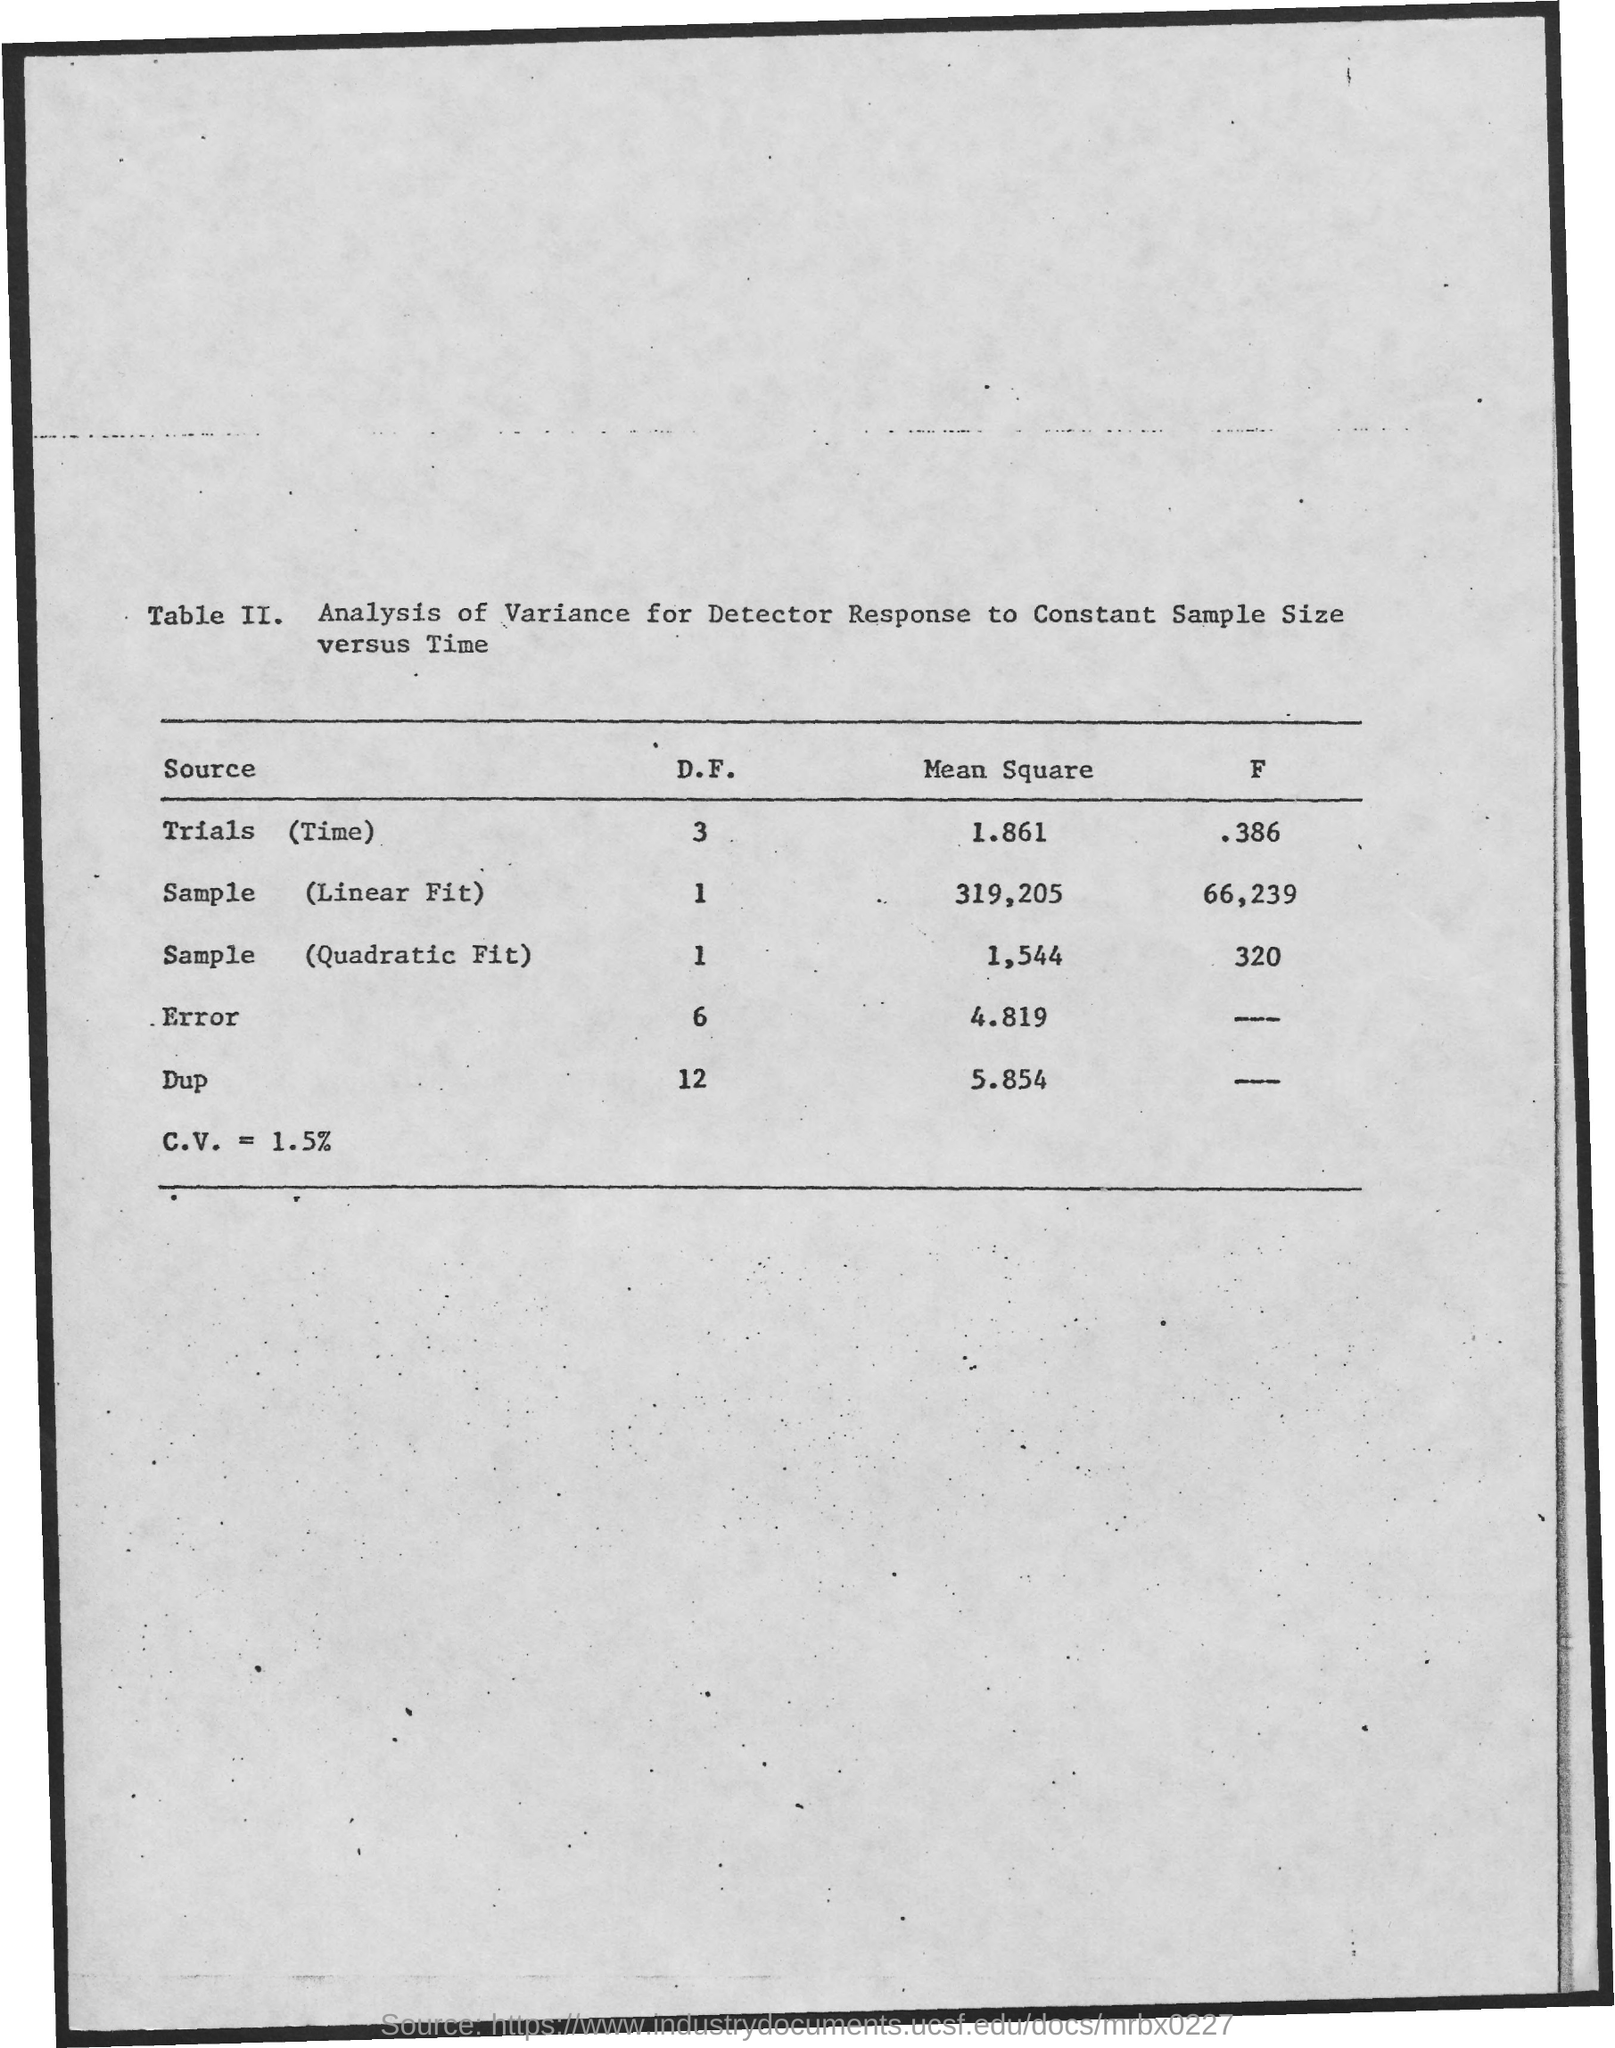What is the Mean Square for Trials (time)?
Your response must be concise. 1.861. What is the Mean Square for Sample (linear fit)?
Offer a very short reply. 319,205. What is the Mean Square for Sample (Quadratic Fit)?
Offer a very short reply. 1,544. What is the Mean Square for error?
Your answer should be very brief. 4.819. What is the Mean Square for Dup?
Your response must be concise. 5.854. What is the D.F. for Trials (time)?
Provide a short and direct response. 3. 